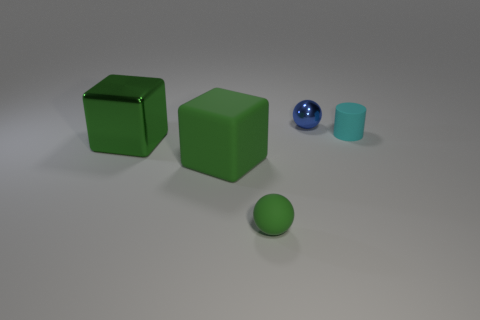Add 4 blue metallic blocks. How many objects exist? 9 Subtract all cylinders. How many objects are left? 4 Subtract 0 green cylinders. How many objects are left? 5 Subtract all blue shiny objects. Subtract all tiny green matte spheres. How many objects are left? 3 Add 2 big things. How many big things are left? 4 Add 4 large green matte cubes. How many large green matte cubes exist? 5 